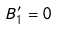Convert formula to latex. <formula><loc_0><loc_0><loc_500><loc_500>B _ { 1 } ^ { \prime } = 0</formula> 